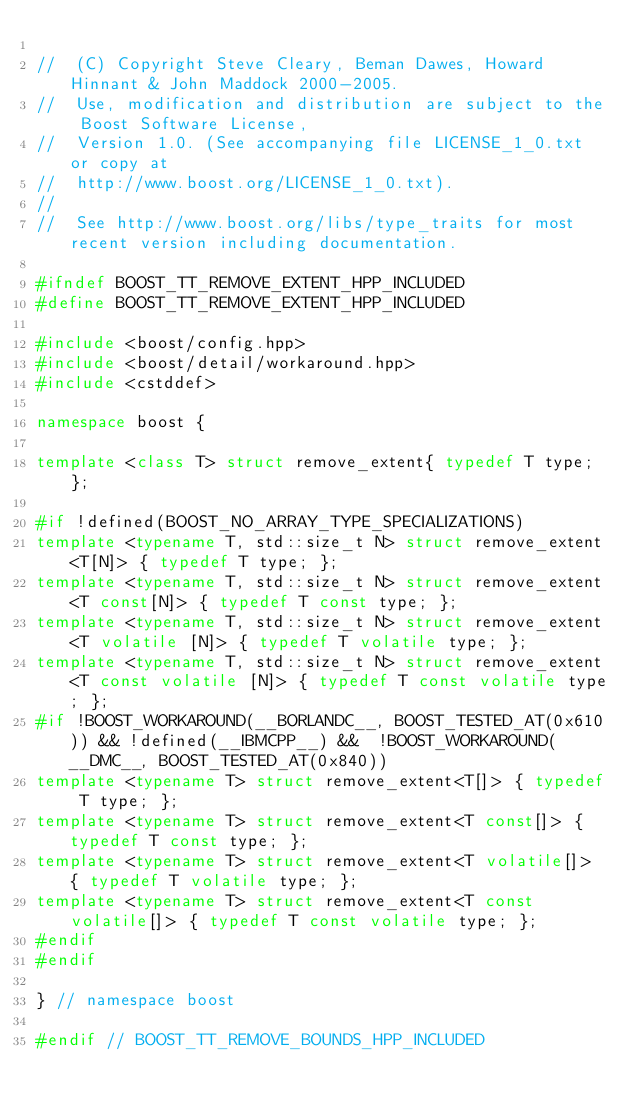<code> <loc_0><loc_0><loc_500><loc_500><_C++_>
//  (C) Copyright Steve Cleary, Beman Dawes, Howard Hinnant & John Maddock 2000-2005.
//  Use, modification and distribution are subject to the Boost Software License,
//  Version 1.0. (See accompanying file LICENSE_1_0.txt or copy at
//  http://www.boost.org/LICENSE_1_0.txt).
//
//  See http://www.boost.org/libs/type_traits for most recent version including documentation.

#ifndef BOOST_TT_REMOVE_EXTENT_HPP_INCLUDED
#define BOOST_TT_REMOVE_EXTENT_HPP_INCLUDED

#include <boost/config.hpp>
#include <boost/detail/workaround.hpp>
#include <cstddef>

namespace boost {

template <class T> struct remove_extent{ typedef T type; };

#if !defined(BOOST_NO_ARRAY_TYPE_SPECIALIZATIONS)
template <typename T, std::size_t N> struct remove_extent<T[N]> { typedef T type; };
template <typename T, std::size_t N> struct remove_extent<T const[N]> { typedef T const type; };
template <typename T, std::size_t N> struct remove_extent<T volatile [N]> { typedef T volatile type; };
template <typename T, std::size_t N> struct remove_extent<T const volatile [N]> { typedef T const volatile type; };
#if !BOOST_WORKAROUND(__BORLANDC__, BOOST_TESTED_AT(0x610)) && !defined(__IBMCPP__) &&  !BOOST_WORKAROUND(__DMC__, BOOST_TESTED_AT(0x840))
template <typename T> struct remove_extent<T[]> { typedef T type; };
template <typename T> struct remove_extent<T const[]> { typedef T const type; };
template <typename T> struct remove_extent<T volatile[]> { typedef T volatile type; };
template <typename T> struct remove_extent<T const volatile[]> { typedef T const volatile type; };
#endif
#endif

} // namespace boost

#endif // BOOST_TT_REMOVE_BOUNDS_HPP_INCLUDED
</code> 